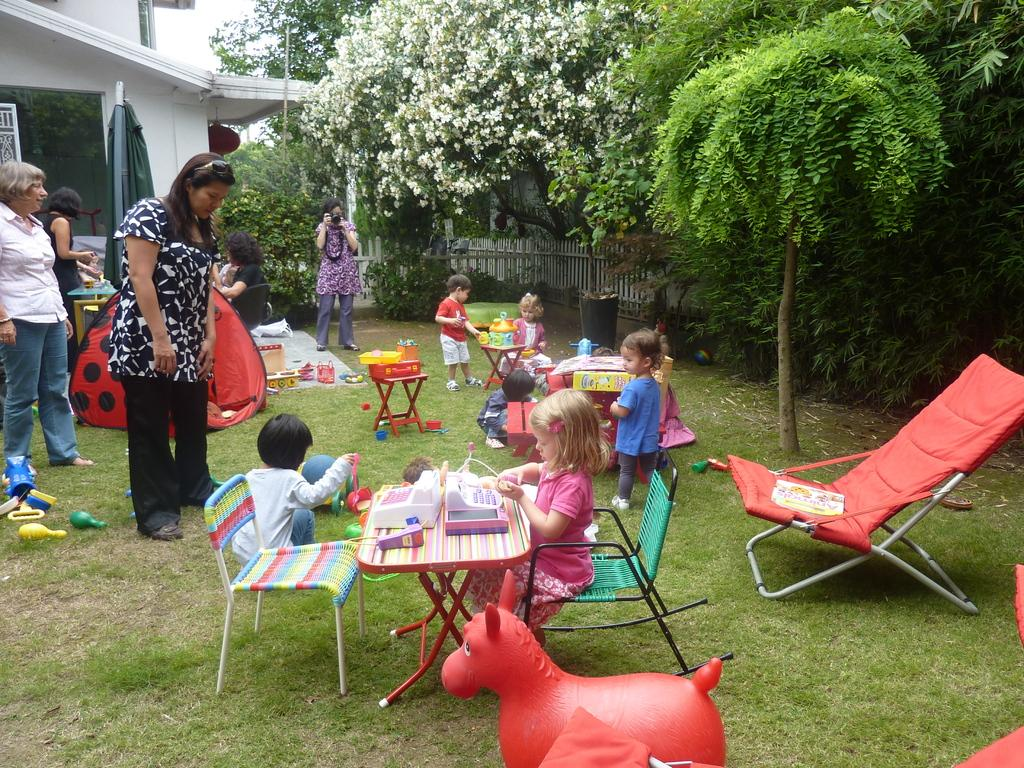Who or what can be seen in the image? There are people in the image. What is on the table in the image? There are objects on a table in the image. What type of vegetation is on the right side of the image? There are trees on the right side of the image. What kind of flowers are visible in the image? White flowers are visible in the image. How many coils can be seen in the image? There is no mention of coils in the image, so it is not possible to determine how many coils are present. 